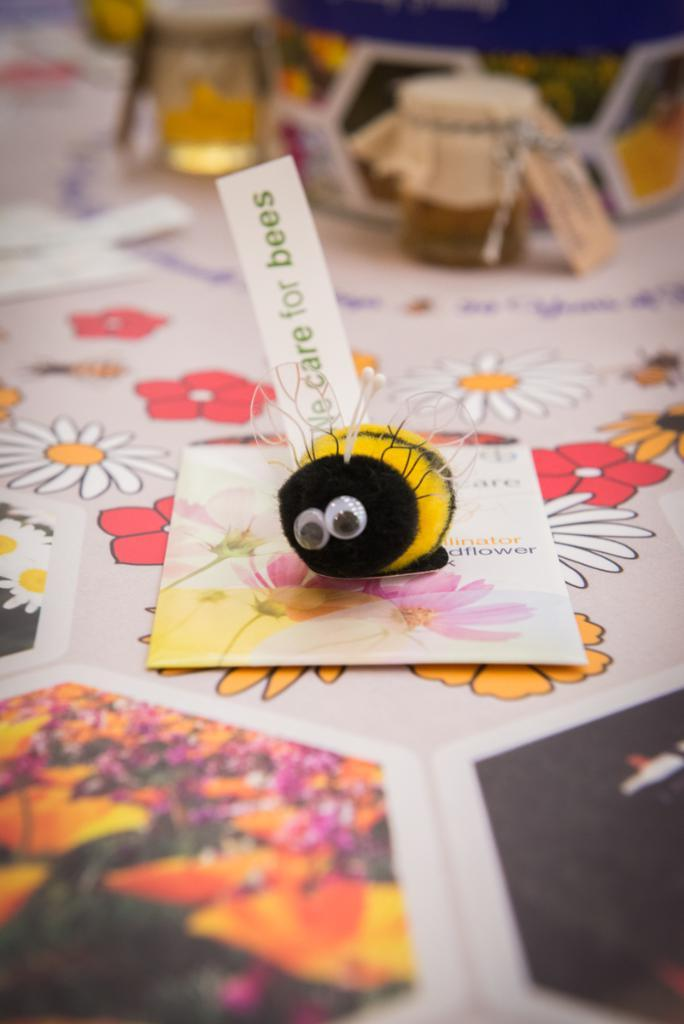<image>
Give a short and clear explanation of the subsequent image. A bee stuffed animal stands on a post card below the message We care for bees. 